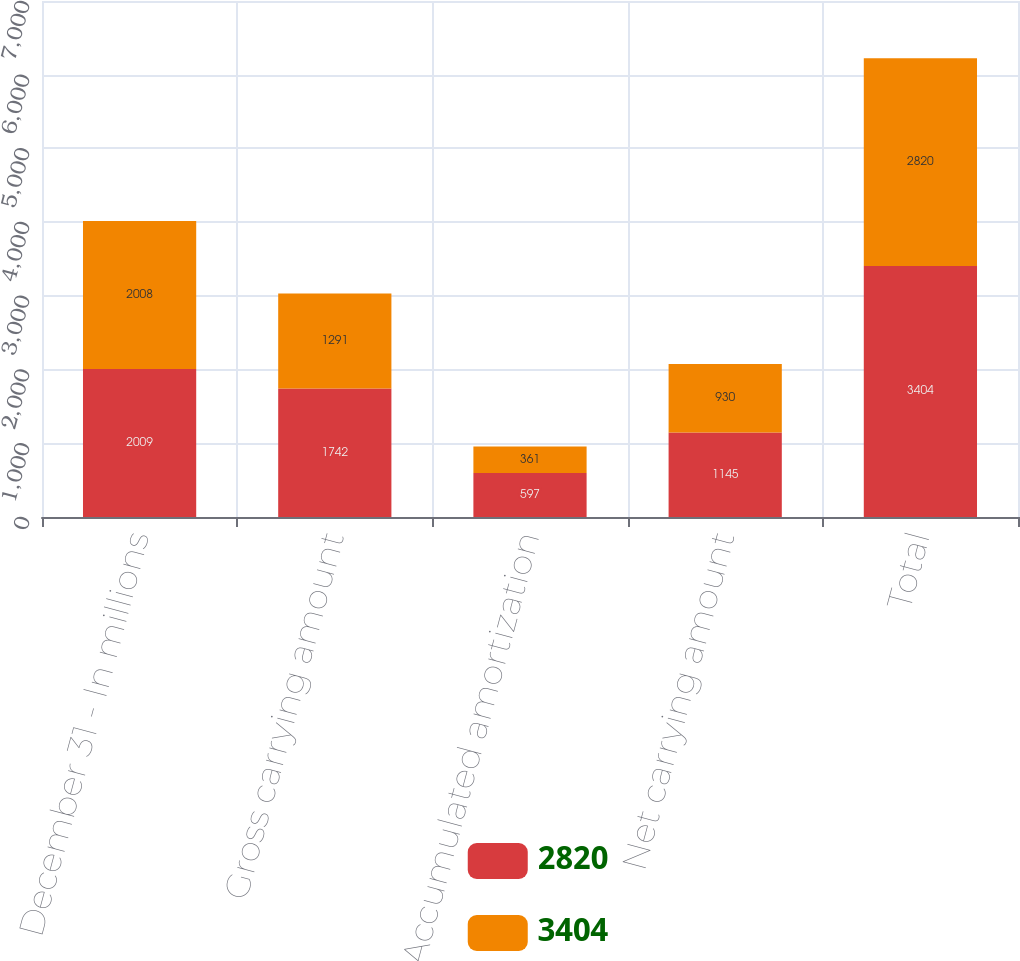<chart> <loc_0><loc_0><loc_500><loc_500><stacked_bar_chart><ecel><fcel>December 31 - In millions<fcel>Gross carrying amount<fcel>Accumulated amortization<fcel>Net carrying amount<fcel>Total<nl><fcel>2820<fcel>2009<fcel>1742<fcel>597<fcel>1145<fcel>3404<nl><fcel>3404<fcel>2008<fcel>1291<fcel>361<fcel>930<fcel>2820<nl></chart> 